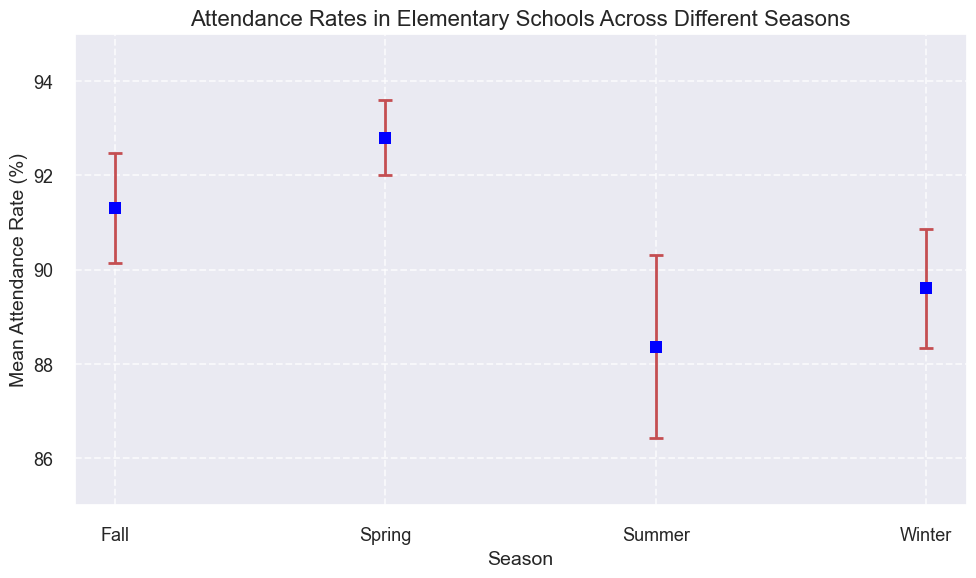Which season has the highest mean attendance rate? To find the highest mean attendance rate, look at the y-values of the points on the plot. Identify which point is the highest.
Answer: Spring How does the mean attendance rate in Winter compare to Summer? Compare the y-values of the points representing Winter and Summer. Winter's mean attendance rate appears higher than Summer's.
Answer: Higher What is the difference in the mean attendance rates between Spring and Fall? Look at the y-values for Spring and Fall. Subtract the Fall value from the Spring value to get the difference.
Answer: 1.5 Which season shows the largest standard error in attendance rates? The standard error is represented by the length of the error bars. Identify the season with the longest error bar.
Answer: Summer What is the average mean attendance rate across all seasons? Sum up the mean attendance rates of all seasons and divide by the number of seasons (4). \( (89.6 + 92.8 + 88.4 + 91.3)/4 = 362.1/4 = 90.525 \).
Answer: 90.5 Between Spring and Summer, which season has a smaller standard error? Look at the lengths of the error bars for Spring and Summer. The shorter bar indicates a smaller standard error.
Answer: Spring Compare the standard errors of Winter and Fall, which is greater? Observe the lengths of the error bars for Winter and Fall. The longer bar represents a greater standard error.
Answer: Winter What is the sum of the mean attendance rates for Summer and Winter? Add the mean attendance rates for Summer and Winter. \( 88.4 + 89.6 = 178 \).
Answer: 178 How much does the mean attendance rate in Fall deviate from the overall average attendance rate? First, calculate the overall average attendance rate (\( 90.5 \)). Then find the difference between the Fall mean attendance rate (\( 91.3 \)) and the overall average. \( 91.3 - 90.5 = 0.8 \).
Answer: 0.8 Which season's mean attendance rate is closest to 90%? Check the points on the y-axis to see which season's mean attendance rate is closest to 90%. The Winter rate is approximately 89.6%, which is closest.
Answer: Winter 